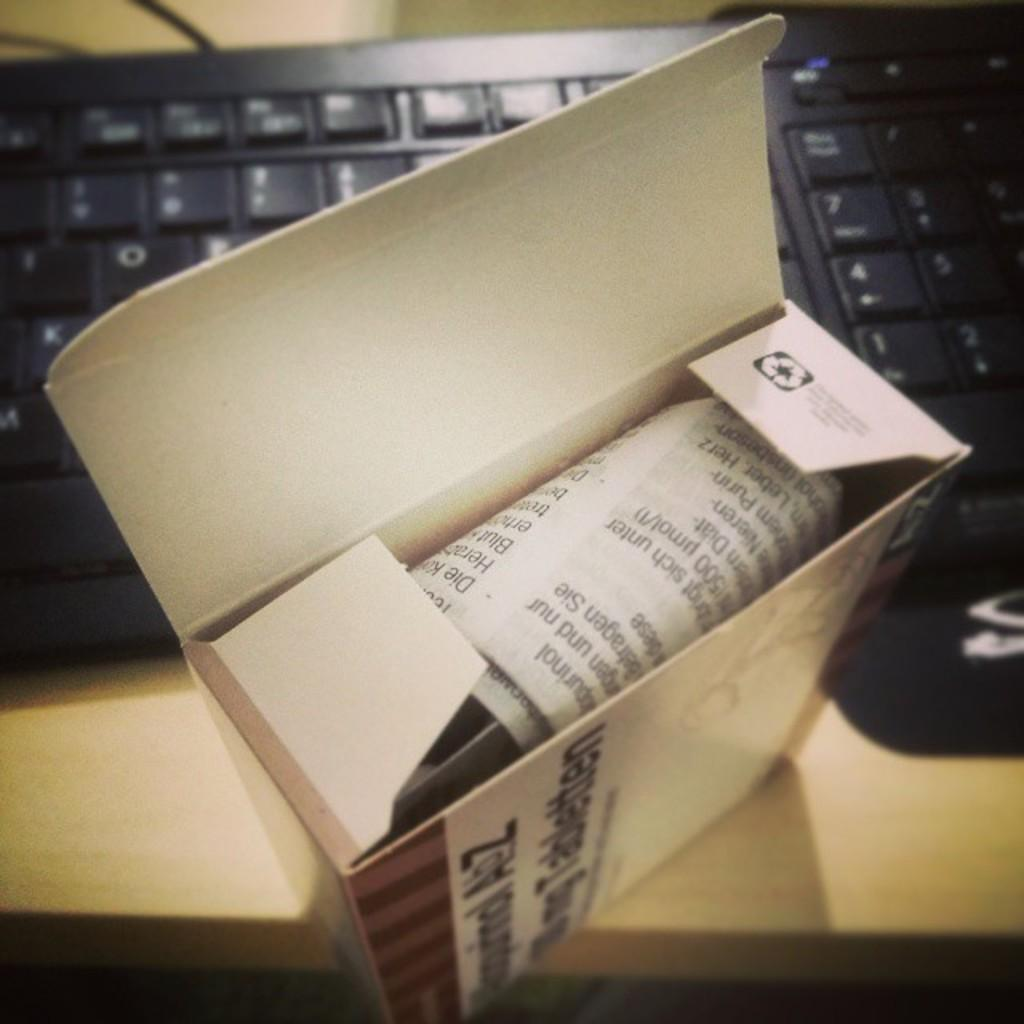<image>
Offer a succinct explanation of the picture presented. An open box with the letters A and Z on the side of it sitting in front of a keyboard. 